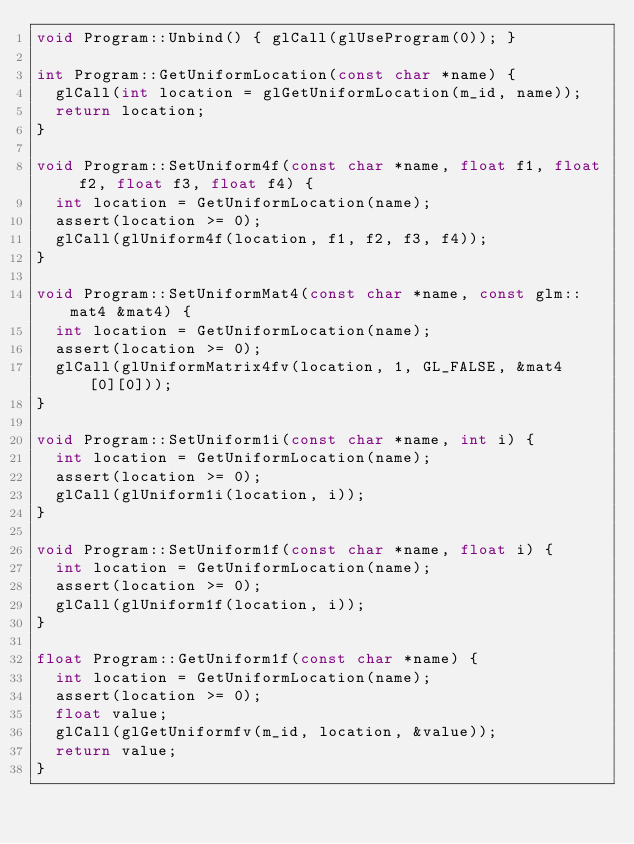<code> <loc_0><loc_0><loc_500><loc_500><_C++_>void Program::Unbind() { glCall(glUseProgram(0)); }

int Program::GetUniformLocation(const char *name) {
  glCall(int location = glGetUniformLocation(m_id, name));
  return location;
}

void Program::SetUniform4f(const char *name, float f1, float f2, float f3, float f4) {
  int location = GetUniformLocation(name);
  assert(location >= 0);
  glCall(glUniform4f(location, f1, f2, f3, f4));
}

void Program::SetUniformMat4(const char *name, const glm::mat4 &mat4) {
  int location = GetUniformLocation(name);
  assert(location >= 0);
  glCall(glUniformMatrix4fv(location, 1, GL_FALSE, &mat4[0][0]));
}

void Program::SetUniform1i(const char *name, int i) {
  int location = GetUniformLocation(name);
  assert(location >= 0);
  glCall(glUniform1i(location, i));
}

void Program::SetUniform1f(const char *name, float i) {
  int location = GetUniformLocation(name);
  assert(location >= 0);
  glCall(glUniform1f(location, i));
}

float Program::GetUniform1f(const char *name) {
  int location = GetUniformLocation(name);
  assert(location >= 0);
  float value;
  glCall(glGetUniformfv(m_id, location, &value));
  return value;
}</code> 